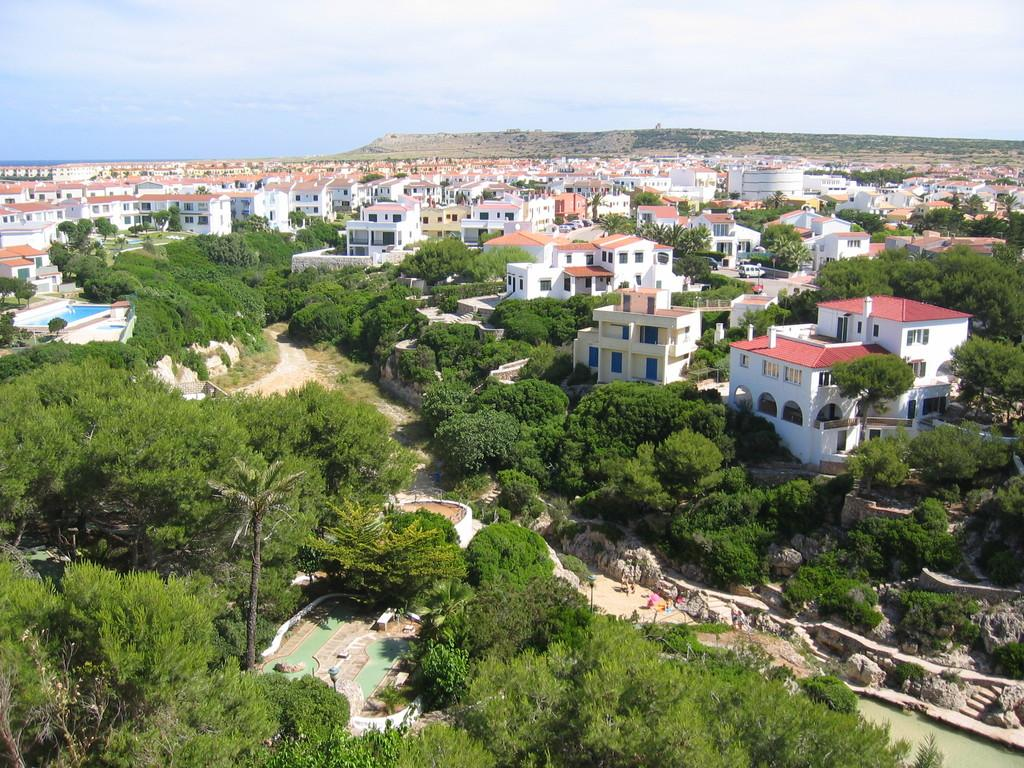What type of view is depicted in the image? The image is an aerial view. What natural elements can be seen in the image? There are trees, water, rocks, and hills visible in the image. Are there any man-made structures in the image? Yes, there are steps and buildings visible in the image. What part of the natural environment is visible in the background of the image? The sky is visible in the background of the image. Where is the lamp placed in the image? There is no lamp present in the image. How many houses can be seen in the image? There are no houses visible in the image. 